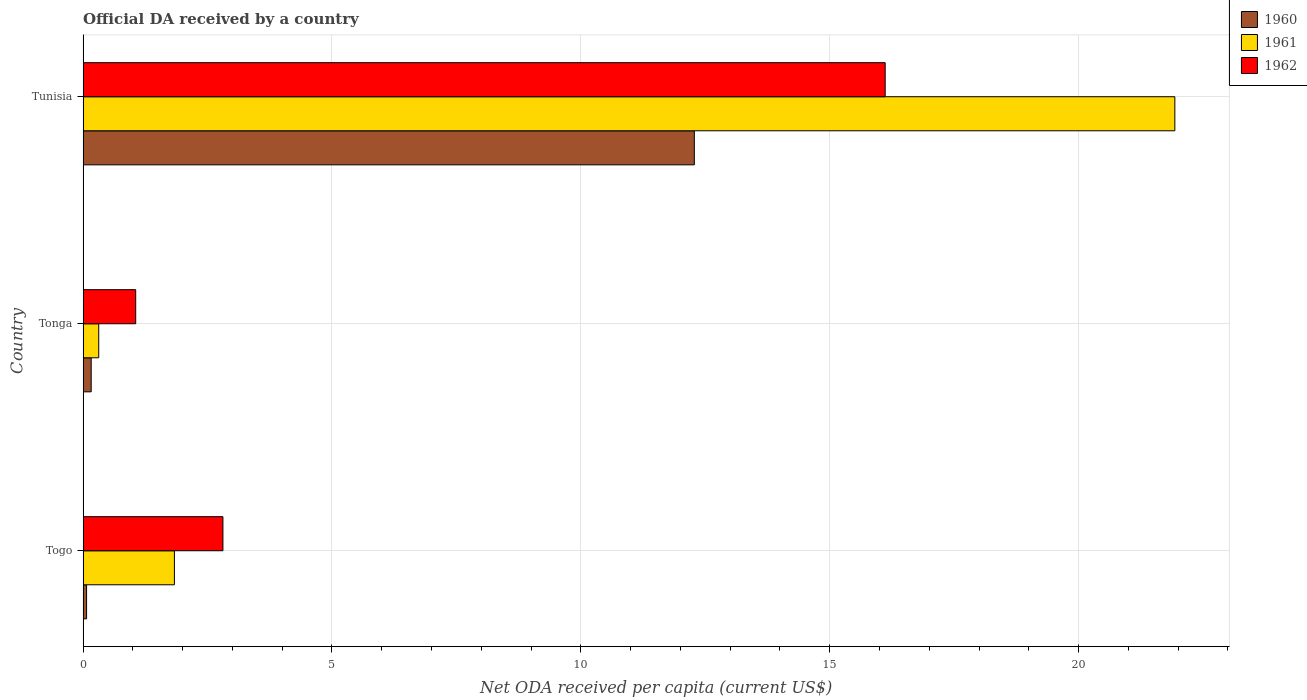How many different coloured bars are there?
Ensure brevity in your answer.  3. What is the label of the 3rd group of bars from the top?
Provide a short and direct response. Togo. In how many cases, is the number of bars for a given country not equal to the number of legend labels?
Offer a very short reply. 0. What is the ODA received in in 1960 in Tunisia?
Keep it short and to the point. 12.28. Across all countries, what is the maximum ODA received in in 1960?
Your response must be concise. 12.28. Across all countries, what is the minimum ODA received in in 1960?
Offer a very short reply. 0.07. In which country was the ODA received in in 1960 maximum?
Offer a very short reply. Tunisia. In which country was the ODA received in in 1962 minimum?
Your answer should be very brief. Tonga. What is the total ODA received in in 1961 in the graph?
Give a very brief answer. 24.08. What is the difference between the ODA received in in 1960 in Tonga and that in Tunisia?
Provide a succinct answer. -12.12. What is the difference between the ODA received in in 1962 in Tunisia and the ODA received in in 1961 in Togo?
Provide a short and direct response. 14.28. What is the average ODA received in in 1960 per country?
Your answer should be compact. 4.17. What is the difference between the ODA received in in 1961 and ODA received in in 1962 in Tunisia?
Your answer should be very brief. 5.82. What is the ratio of the ODA received in in 1960 in Togo to that in Tunisia?
Your response must be concise. 0.01. Is the ODA received in in 1961 in Togo less than that in Tonga?
Offer a very short reply. No. What is the difference between the highest and the second highest ODA received in in 1960?
Offer a very short reply. 12.12. What is the difference between the highest and the lowest ODA received in in 1960?
Your answer should be compact. 12.21. In how many countries, is the ODA received in in 1960 greater than the average ODA received in in 1960 taken over all countries?
Provide a succinct answer. 1. Is it the case that in every country, the sum of the ODA received in in 1961 and ODA received in in 1960 is greater than the ODA received in in 1962?
Your response must be concise. No. How many bars are there?
Offer a very short reply. 9. Are all the bars in the graph horizontal?
Provide a short and direct response. Yes. How many countries are there in the graph?
Your answer should be compact. 3. Does the graph contain any zero values?
Ensure brevity in your answer.  No. Does the graph contain grids?
Give a very brief answer. Yes. Where does the legend appear in the graph?
Give a very brief answer. Top right. How many legend labels are there?
Your answer should be compact. 3. How are the legend labels stacked?
Give a very brief answer. Vertical. What is the title of the graph?
Give a very brief answer. Official DA received by a country. What is the label or title of the X-axis?
Keep it short and to the point. Net ODA received per capita (current US$). What is the label or title of the Y-axis?
Your response must be concise. Country. What is the Net ODA received per capita (current US$) of 1960 in Togo?
Your answer should be very brief. 0.07. What is the Net ODA received per capita (current US$) of 1961 in Togo?
Make the answer very short. 1.83. What is the Net ODA received per capita (current US$) in 1962 in Togo?
Your answer should be compact. 2.81. What is the Net ODA received per capita (current US$) in 1960 in Tonga?
Your response must be concise. 0.16. What is the Net ODA received per capita (current US$) in 1961 in Tonga?
Your response must be concise. 0.31. What is the Net ODA received per capita (current US$) of 1962 in Tonga?
Your response must be concise. 1.06. What is the Net ODA received per capita (current US$) in 1960 in Tunisia?
Ensure brevity in your answer.  12.28. What is the Net ODA received per capita (current US$) of 1961 in Tunisia?
Ensure brevity in your answer.  21.93. What is the Net ODA received per capita (current US$) of 1962 in Tunisia?
Offer a very short reply. 16.11. Across all countries, what is the maximum Net ODA received per capita (current US$) in 1960?
Offer a very short reply. 12.28. Across all countries, what is the maximum Net ODA received per capita (current US$) of 1961?
Keep it short and to the point. 21.93. Across all countries, what is the maximum Net ODA received per capita (current US$) in 1962?
Keep it short and to the point. 16.11. Across all countries, what is the minimum Net ODA received per capita (current US$) of 1960?
Offer a terse response. 0.07. Across all countries, what is the minimum Net ODA received per capita (current US$) in 1961?
Your answer should be very brief. 0.31. Across all countries, what is the minimum Net ODA received per capita (current US$) in 1962?
Ensure brevity in your answer.  1.06. What is the total Net ODA received per capita (current US$) of 1960 in the graph?
Offer a very short reply. 12.51. What is the total Net ODA received per capita (current US$) of 1961 in the graph?
Offer a very short reply. 24.08. What is the total Net ODA received per capita (current US$) of 1962 in the graph?
Offer a very short reply. 19.98. What is the difference between the Net ODA received per capita (current US$) in 1960 in Togo and that in Tonga?
Provide a succinct answer. -0.09. What is the difference between the Net ODA received per capita (current US$) in 1961 in Togo and that in Tonga?
Offer a terse response. 1.52. What is the difference between the Net ODA received per capita (current US$) of 1962 in Togo and that in Tonga?
Your answer should be compact. 1.75. What is the difference between the Net ODA received per capita (current US$) of 1960 in Togo and that in Tunisia?
Provide a succinct answer. -12.21. What is the difference between the Net ODA received per capita (current US$) in 1961 in Togo and that in Tunisia?
Your answer should be compact. -20.1. What is the difference between the Net ODA received per capita (current US$) in 1962 in Togo and that in Tunisia?
Give a very brief answer. -13.31. What is the difference between the Net ODA received per capita (current US$) of 1960 in Tonga and that in Tunisia?
Provide a succinct answer. -12.12. What is the difference between the Net ODA received per capita (current US$) of 1961 in Tonga and that in Tunisia?
Ensure brevity in your answer.  -21.62. What is the difference between the Net ODA received per capita (current US$) of 1962 in Tonga and that in Tunisia?
Ensure brevity in your answer.  -15.06. What is the difference between the Net ODA received per capita (current US$) in 1960 in Togo and the Net ODA received per capita (current US$) in 1961 in Tonga?
Offer a very short reply. -0.24. What is the difference between the Net ODA received per capita (current US$) of 1960 in Togo and the Net ODA received per capita (current US$) of 1962 in Tonga?
Your answer should be very brief. -0.99. What is the difference between the Net ODA received per capita (current US$) in 1961 in Togo and the Net ODA received per capita (current US$) in 1962 in Tonga?
Keep it short and to the point. 0.78. What is the difference between the Net ODA received per capita (current US$) in 1960 in Togo and the Net ODA received per capita (current US$) in 1961 in Tunisia?
Provide a short and direct response. -21.86. What is the difference between the Net ODA received per capita (current US$) of 1960 in Togo and the Net ODA received per capita (current US$) of 1962 in Tunisia?
Provide a short and direct response. -16.04. What is the difference between the Net ODA received per capita (current US$) of 1961 in Togo and the Net ODA received per capita (current US$) of 1962 in Tunisia?
Offer a terse response. -14.28. What is the difference between the Net ODA received per capita (current US$) of 1960 in Tonga and the Net ODA received per capita (current US$) of 1961 in Tunisia?
Offer a very short reply. -21.77. What is the difference between the Net ODA received per capita (current US$) in 1960 in Tonga and the Net ODA received per capita (current US$) in 1962 in Tunisia?
Give a very brief answer. -15.95. What is the difference between the Net ODA received per capita (current US$) in 1961 in Tonga and the Net ODA received per capita (current US$) in 1962 in Tunisia?
Your answer should be very brief. -15.8. What is the average Net ODA received per capita (current US$) in 1960 per country?
Your response must be concise. 4.17. What is the average Net ODA received per capita (current US$) in 1961 per country?
Provide a short and direct response. 8.03. What is the average Net ODA received per capita (current US$) of 1962 per country?
Offer a terse response. 6.66. What is the difference between the Net ODA received per capita (current US$) of 1960 and Net ODA received per capita (current US$) of 1961 in Togo?
Offer a terse response. -1.76. What is the difference between the Net ODA received per capita (current US$) of 1960 and Net ODA received per capita (current US$) of 1962 in Togo?
Make the answer very short. -2.74. What is the difference between the Net ODA received per capita (current US$) in 1961 and Net ODA received per capita (current US$) in 1962 in Togo?
Your answer should be very brief. -0.97. What is the difference between the Net ODA received per capita (current US$) in 1960 and Net ODA received per capita (current US$) in 1961 in Tonga?
Your response must be concise. -0.15. What is the difference between the Net ODA received per capita (current US$) in 1960 and Net ODA received per capita (current US$) in 1962 in Tonga?
Offer a terse response. -0.89. What is the difference between the Net ODA received per capita (current US$) in 1961 and Net ODA received per capita (current US$) in 1962 in Tonga?
Your response must be concise. -0.74. What is the difference between the Net ODA received per capita (current US$) of 1960 and Net ODA received per capita (current US$) of 1961 in Tunisia?
Offer a very short reply. -9.65. What is the difference between the Net ODA received per capita (current US$) in 1960 and Net ODA received per capita (current US$) in 1962 in Tunisia?
Offer a terse response. -3.83. What is the difference between the Net ODA received per capita (current US$) of 1961 and Net ODA received per capita (current US$) of 1962 in Tunisia?
Your answer should be very brief. 5.82. What is the ratio of the Net ODA received per capita (current US$) of 1960 in Togo to that in Tonga?
Make the answer very short. 0.43. What is the ratio of the Net ODA received per capita (current US$) of 1961 in Togo to that in Tonga?
Offer a very short reply. 5.85. What is the ratio of the Net ODA received per capita (current US$) of 1962 in Togo to that in Tonga?
Provide a short and direct response. 2.66. What is the ratio of the Net ODA received per capita (current US$) of 1960 in Togo to that in Tunisia?
Give a very brief answer. 0.01. What is the ratio of the Net ODA received per capita (current US$) of 1961 in Togo to that in Tunisia?
Provide a short and direct response. 0.08. What is the ratio of the Net ODA received per capita (current US$) in 1962 in Togo to that in Tunisia?
Provide a short and direct response. 0.17. What is the ratio of the Net ODA received per capita (current US$) in 1960 in Tonga to that in Tunisia?
Your answer should be very brief. 0.01. What is the ratio of the Net ODA received per capita (current US$) in 1961 in Tonga to that in Tunisia?
Offer a very short reply. 0.01. What is the ratio of the Net ODA received per capita (current US$) of 1962 in Tonga to that in Tunisia?
Ensure brevity in your answer.  0.07. What is the difference between the highest and the second highest Net ODA received per capita (current US$) in 1960?
Offer a very short reply. 12.12. What is the difference between the highest and the second highest Net ODA received per capita (current US$) in 1961?
Make the answer very short. 20.1. What is the difference between the highest and the second highest Net ODA received per capita (current US$) of 1962?
Your answer should be very brief. 13.31. What is the difference between the highest and the lowest Net ODA received per capita (current US$) of 1960?
Give a very brief answer. 12.21. What is the difference between the highest and the lowest Net ODA received per capita (current US$) of 1961?
Your answer should be compact. 21.62. What is the difference between the highest and the lowest Net ODA received per capita (current US$) in 1962?
Make the answer very short. 15.06. 